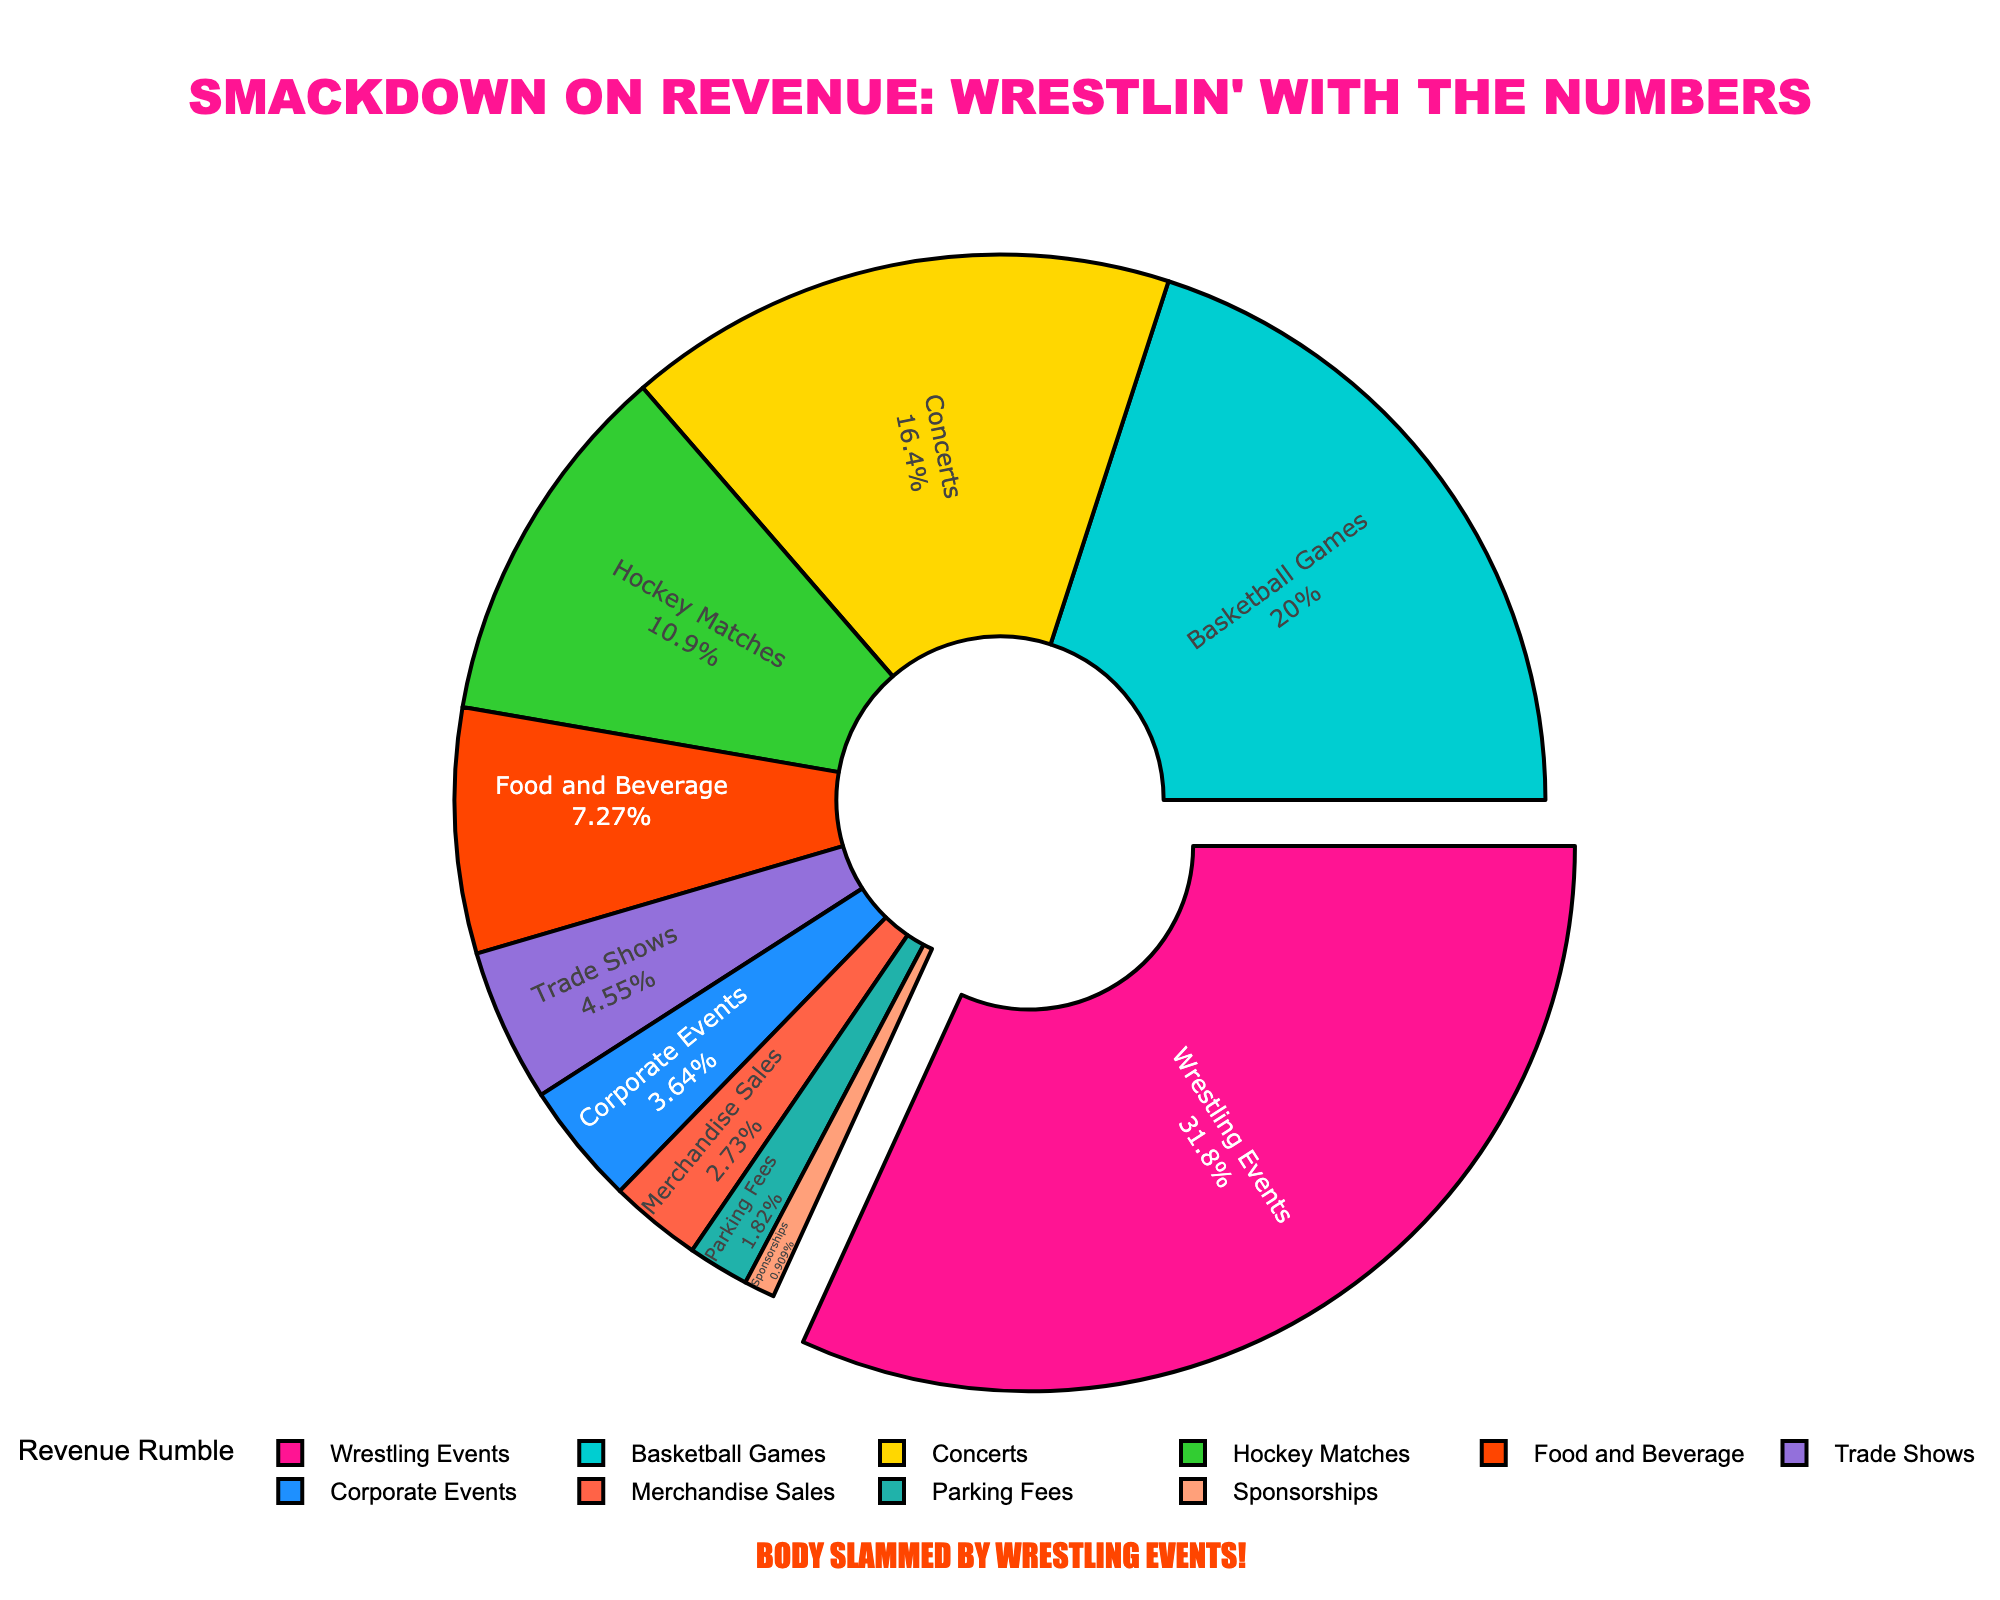What percentage of revenue comes from concerts and corporate events combined? Look at the pie chart to find the percentages for Concerts (18%) and Corporate Events (4%). Sum these values: 18 + 4 = 22%
Answer: 22% Which revenue source generates the most revenue? Identify the largest segment in the pie chart, labeled as Wrestling Events, which occupies 35% of the chart.
Answer: Wrestling Events How does the revenue from food and beverage compare to merchandise sales? Look at the sections labeled Food and Beverage (8%) and Merchandise Sales (3%). Compare their percentages: 8% > 3%.
Answer: Food and Beverage generates more revenue than Merchandise Sales What do parking fees and sponsorships contribute to the total revenue? Find the segments for Parking Fees (2%) and Sponsorships (1%) in the pie chart. Sum these values: 2 + 1 = 3%.
Answer: 3% Which category, hockey matches or trade shows, contributes a higher percentage to the total revenue? Compare the percentages given: Hockey Matches (12%) and Trade Shows (5%). 12% > 5%, so Hockey Matches contribute more.
Answer: Hockey Matches If you combine the revenue from basketball games and food and beverage, what percentage of the total does it represent? Find the segments for Basketball Games (22%) and Food and Beverage (8%). Sum these values: 22 + 8 = 30%.
Answer: 30% Which sections are represented by shades of blue, and what are their percentages? Identify the blue-colored sections in the pie chart: Basketball Games (22%) and Sponsorships (1%).
Answer: Basketball Games (22%) and Sponsorships (1%) What revenue sources make up exactly 10% of the total when combined? Look for small segments that add up to 10%: Merchandise Sales (3%) and Parking Fees (2%) combined with Sponsorships (1%), giving 6%. Adding Trade Shows (5%) to this sum equals 11%, which is over 10%, so conclude Trade Shows cannot be included, limiting the combination to Merchandise Sales, Parking Fees, and Sponsorships.
Answer: Merchandise Sales (3%), Parking Fees (2%), and Sponsorships (1%) Which event generates the least revenue according to the pie chart? Look at the smallest segment of the pie chart, labeled as Sponsorships, which represents 1%.
Answer: Sponsorships What is the combined contribution of the three lowest revenue sources? Identify the three lowest revenue sources and sum them: Sponsorships (1%), Parking Fees (2%), and Merchandise Sales (3%). Sum: 1 + 2 + 3 = 6%.
Answer: 6% 